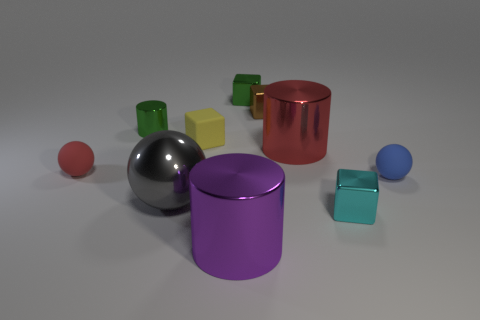Subtract all purple cylinders. How many cylinders are left? 2 Subtract 2 cylinders. How many cylinders are left? 1 Subtract all green spheres. Subtract all cyan blocks. How many spheres are left? 3 Subtract all cyan blocks. How many red spheres are left? 1 Subtract all tiny cyan metal cylinders. Subtract all big things. How many objects are left? 7 Add 4 tiny metal cylinders. How many tiny metal cylinders are left? 5 Add 5 small cylinders. How many small cylinders exist? 6 Subtract all purple cylinders. How many cylinders are left? 2 Subtract 0 blue cylinders. How many objects are left? 10 Subtract all spheres. How many objects are left? 7 